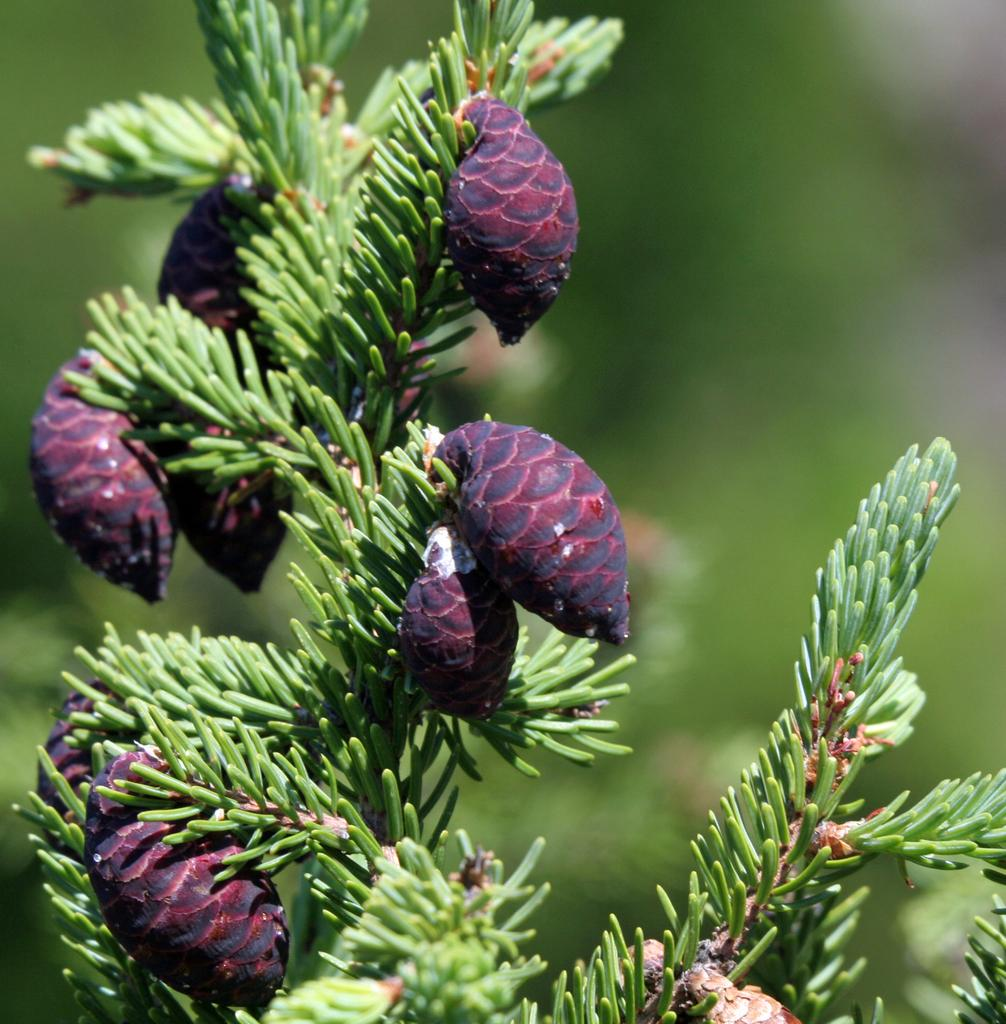What is present on the plant in the image? There are buds on a plant in the image. What color are the bugs in the image? The bugs are in pink color. Can you describe the background of the image? The background of the image is blurred. What type of juice can be seen being squeezed from the buds in the image? There is no juice being squeezed from the buds in the image; the buds are simply present on the plant. 